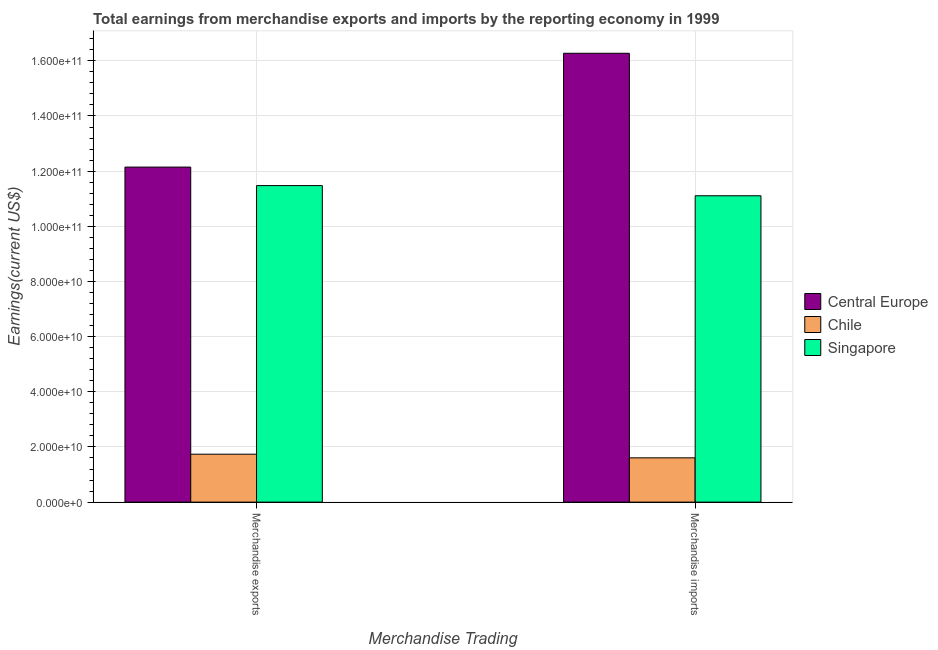Are the number of bars per tick equal to the number of legend labels?
Your answer should be compact. Yes. How many bars are there on the 1st tick from the right?
Your answer should be very brief. 3. What is the earnings from merchandise exports in Central Europe?
Provide a short and direct response. 1.21e+11. Across all countries, what is the maximum earnings from merchandise exports?
Your answer should be compact. 1.21e+11. Across all countries, what is the minimum earnings from merchandise exports?
Offer a very short reply. 1.74e+1. In which country was the earnings from merchandise imports maximum?
Offer a terse response. Central Europe. What is the total earnings from merchandise exports in the graph?
Provide a succinct answer. 2.54e+11. What is the difference between the earnings from merchandise imports in Singapore and that in Chile?
Keep it short and to the point. 9.50e+1. What is the difference between the earnings from merchandise imports in Chile and the earnings from merchandise exports in Central Europe?
Provide a succinct answer. -1.05e+11. What is the average earnings from merchandise imports per country?
Your answer should be compact. 9.66e+1. What is the difference between the earnings from merchandise exports and earnings from merchandise imports in Chile?
Your answer should be compact. 1.32e+09. In how many countries, is the earnings from merchandise imports greater than 16000000000 US$?
Your answer should be compact. 3. What is the ratio of the earnings from merchandise imports in Chile to that in Singapore?
Offer a very short reply. 0.14. Is the earnings from merchandise exports in Central Europe less than that in Chile?
Keep it short and to the point. No. In how many countries, is the earnings from merchandise imports greater than the average earnings from merchandise imports taken over all countries?
Offer a terse response. 2. What does the 3rd bar from the left in Merchandise exports represents?
Make the answer very short. Singapore. What does the 2nd bar from the right in Merchandise imports represents?
Your response must be concise. Chile. How many bars are there?
Give a very brief answer. 6. How many countries are there in the graph?
Provide a succinct answer. 3. What is the difference between two consecutive major ticks on the Y-axis?
Give a very brief answer. 2.00e+1. Are the values on the major ticks of Y-axis written in scientific E-notation?
Ensure brevity in your answer.  Yes. Does the graph contain any zero values?
Keep it short and to the point. No. Does the graph contain grids?
Ensure brevity in your answer.  Yes. Where does the legend appear in the graph?
Give a very brief answer. Center right. How many legend labels are there?
Your answer should be compact. 3. How are the legend labels stacked?
Ensure brevity in your answer.  Vertical. What is the title of the graph?
Keep it short and to the point. Total earnings from merchandise exports and imports by the reporting economy in 1999. What is the label or title of the X-axis?
Give a very brief answer. Merchandise Trading. What is the label or title of the Y-axis?
Offer a very short reply. Earnings(current US$). What is the Earnings(current US$) of Central Europe in Merchandise exports?
Offer a terse response. 1.21e+11. What is the Earnings(current US$) in Chile in Merchandise exports?
Ensure brevity in your answer.  1.74e+1. What is the Earnings(current US$) of Singapore in Merchandise exports?
Your response must be concise. 1.15e+11. What is the Earnings(current US$) in Central Europe in Merchandise imports?
Make the answer very short. 1.63e+11. What is the Earnings(current US$) of Chile in Merchandise imports?
Provide a succinct answer. 1.61e+1. What is the Earnings(current US$) in Singapore in Merchandise imports?
Provide a short and direct response. 1.11e+11. Across all Merchandise Trading, what is the maximum Earnings(current US$) of Central Europe?
Ensure brevity in your answer.  1.63e+11. Across all Merchandise Trading, what is the maximum Earnings(current US$) of Chile?
Your response must be concise. 1.74e+1. Across all Merchandise Trading, what is the maximum Earnings(current US$) in Singapore?
Provide a succinct answer. 1.15e+11. Across all Merchandise Trading, what is the minimum Earnings(current US$) in Central Europe?
Provide a succinct answer. 1.21e+11. Across all Merchandise Trading, what is the minimum Earnings(current US$) of Chile?
Keep it short and to the point. 1.61e+1. Across all Merchandise Trading, what is the minimum Earnings(current US$) in Singapore?
Make the answer very short. 1.11e+11. What is the total Earnings(current US$) of Central Europe in the graph?
Make the answer very short. 2.84e+11. What is the total Earnings(current US$) in Chile in the graph?
Provide a short and direct response. 3.34e+1. What is the total Earnings(current US$) of Singapore in the graph?
Your answer should be very brief. 2.26e+11. What is the difference between the Earnings(current US$) of Central Europe in Merchandise exports and that in Merchandise imports?
Your answer should be compact. -4.13e+1. What is the difference between the Earnings(current US$) of Chile in Merchandise exports and that in Merchandise imports?
Keep it short and to the point. 1.32e+09. What is the difference between the Earnings(current US$) in Singapore in Merchandise exports and that in Merchandise imports?
Keep it short and to the point. 3.68e+09. What is the difference between the Earnings(current US$) of Central Europe in Merchandise exports and the Earnings(current US$) of Chile in Merchandise imports?
Offer a terse response. 1.05e+11. What is the difference between the Earnings(current US$) in Central Europe in Merchandise exports and the Earnings(current US$) in Singapore in Merchandise imports?
Provide a succinct answer. 1.04e+1. What is the difference between the Earnings(current US$) of Chile in Merchandise exports and the Earnings(current US$) of Singapore in Merchandise imports?
Your answer should be compact. -9.37e+1. What is the average Earnings(current US$) of Central Europe per Merchandise Trading?
Your answer should be compact. 1.42e+11. What is the average Earnings(current US$) in Chile per Merchandise Trading?
Make the answer very short. 1.67e+1. What is the average Earnings(current US$) in Singapore per Merchandise Trading?
Your answer should be very brief. 1.13e+11. What is the difference between the Earnings(current US$) in Central Europe and Earnings(current US$) in Chile in Merchandise exports?
Provide a short and direct response. 1.04e+11. What is the difference between the Earnings(current US$) of Central Europe and Earnings(current US$) of Singapore in Merchandise exports?
Make the answer very short. 6.71e+09. What is the difference between the Earnings(current US$) in Chile and Earnings(current US$) in Singapore in Merchandise exports?
Offer a terse response. -9.74e+1. What is the difference between the Earnings(current US$) in Central Europe and Earnings(current US$) in Chile in Merchandise imports?
Your response must be concise. 1.47e+11. What is the difference between the Earnings(current US$) of Central Europe and Earnings(current US$) of Singapore in Merchandise imports?
Keep it short and to the point. 5.17e+1. What is the difference between the Earnings(current US$) in Chile and Earnings(current US$) in Singapore in Merchandise imports?
Your answer should be very brief. -9.50e+1. What is the ratio of the Earnings(current US$) in Central Europe in Merchandise exports to that in Merchandise imports?
Keep it short and to the point. 0.75. What is the ratio of the Earnings(current US$) in Chile in Merchandise exports to that in Merchandise imports?
Your answer should be very brief. 1.08. What is the ratio of the Earnings(current US$) of Singapore in Merchandise exports to that in Merchandise imports?
Make the answer very short. 1.03. What is the difference between the highest and the second highest Earnings(current US$) of Central Europe?
Keep it short and to the point. 4.13e+1. What is the difference between the highest and the second highest Earnings(current US$) of Chile?
Ensure brevity in your answer.  1.32e+09. What is the difference between the highest and the second highest Earnings(current US$) of Singapore?
Your answer should be compact. 3.68e+09. What is the difference between the highest and the lowest Earnings(current US$) in Central Europe?
Your response must be concise. 4.13e+1. What is the difference between the highest and the lowest Earnings(current US$) in Chile?
Your response must be concise. 1.32e+09. What is the difference between the highest and the lowest Earnings(current US$) in Singapore?
Give a very brief answer. 3.68e+09. 